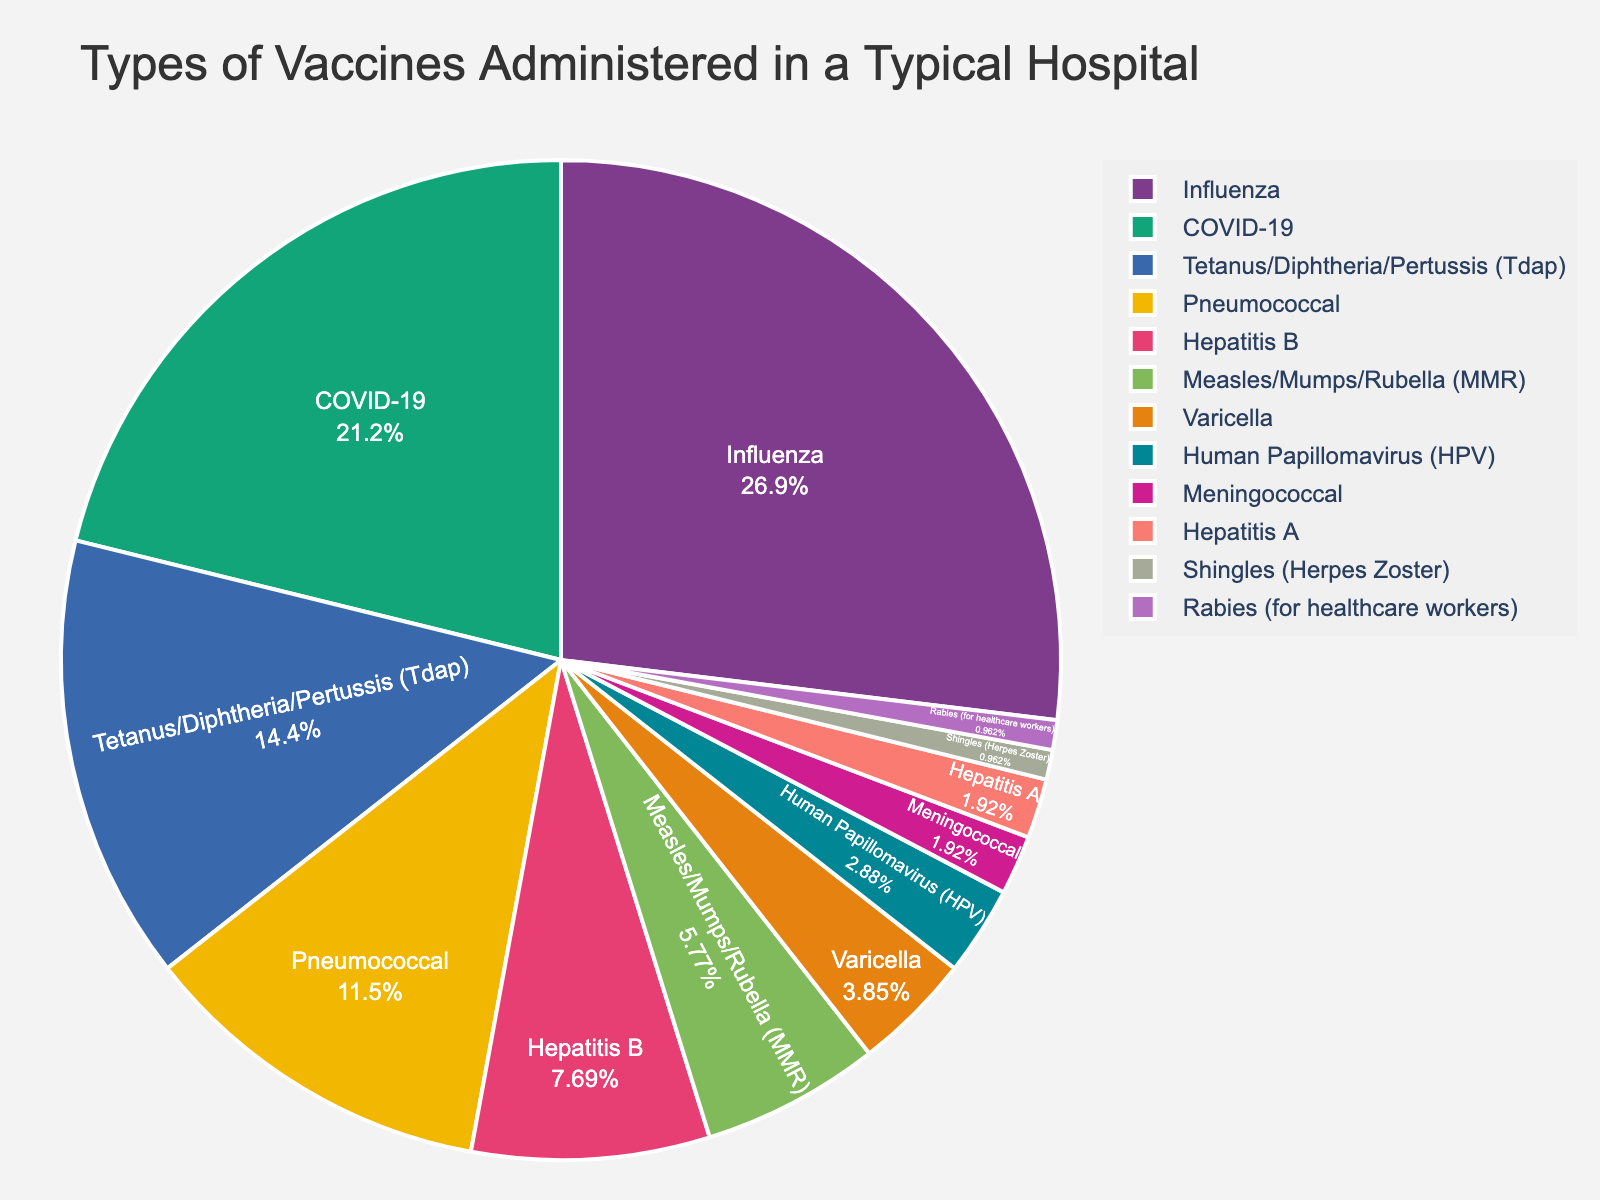what percentage of vaccines administered are either Pneumococcal or COVID-19? To find this, add the percentages for Pneumococcal (12%) and COVID-19 (22%). The total is 12% + 22% = 34%.
Answer: 34% how many times more prevalent is the Influenza vaccine compared to the Rabies vaccine? To find this, divide the percentage of the Influenza vaccine (28%) by the percentage of the Rabies vaccine (1%). Thus, 28 / 1 = 28 times.
Answer: 28 times which vaccine is represented by the smallest percentage, and what is that percentage? The smallest percentage is represented by the Shingles (Herpes Zoster) and Rabies vaccines, both at 1%.
Answer: Shingles (Herpes Zoster) and Rabies, 1% are there more vaccines administered for Measles/Mumps/Rubella (MMR) or Hepatitis B? Compare the percentages: MMR is at 6% and Hepatitis B is at 8%. Since 8% is higher than 6%, more vaccines are administered for Hepatitis B.
Answer: Hepatitis B what is the total percentage of all vaccines administered that make up less than 5% each? Sum the percentages for Varicella (4%), Human Papillomavirus (HPV) (3%), Meningococcal (2%), Hepatitis A (2%), Shingles (Herpes Zoster) (1%), and Rabies (1%). The total is 4% + 3% + 2% + 2% + 1% + 1% = 13%.
Answer: 13% what is the combined percentage for all types of vaccines except the top two by percentage? First, identify the top two vaccines by percentage: Influenza (28%) and COVID-19 (22%). The combined percentage for these two is 28% + 22% = 50%. Subtract this from 100% to find the combined percentage for the rest: 100% - 50% = 50%.
Answer: 50% which vaccine type has a percentage midway between Tetanus/Diphtheria/Pertussis (Tdap) and Measles/Mumps/Rubella (MMR)? Tdap is 15% and MMR is 6%. Their average is \( \frac{15 + 6}{2} = 10.5\% \). The type closest to 10.5% is Hepatitis B at 8%.
Answer: Hepatitis B if the plot was shaded with colors starting from red for the highest percentage to blue for the lowest percentage, which vaccine type would be shaded green? Green would be somewhere in the middle. Tdap at 15% is roughly the middle percentage, likely to be shaded green.
Answer: Tetanus/Diphtheria/Pertussis (Tdap) between the vaccines Varicella and Human Papillomavirus (HPV), which one is given less frequently? Compare the percentages: Varicella is at 4% and HPV is at 3%. Since 3% is lower than 4%, HPV is given less frequently.
Answer: Human Papillomavirus (HPV) what is the difference in percentage between the most and least administered vaccines? The most administered vaccine is Influenza at 28%, and the least are Shingles (Herpes Zoster) and Rabies at 1%. The difference is 28% - 1% = 27%.
Answer: 27% 